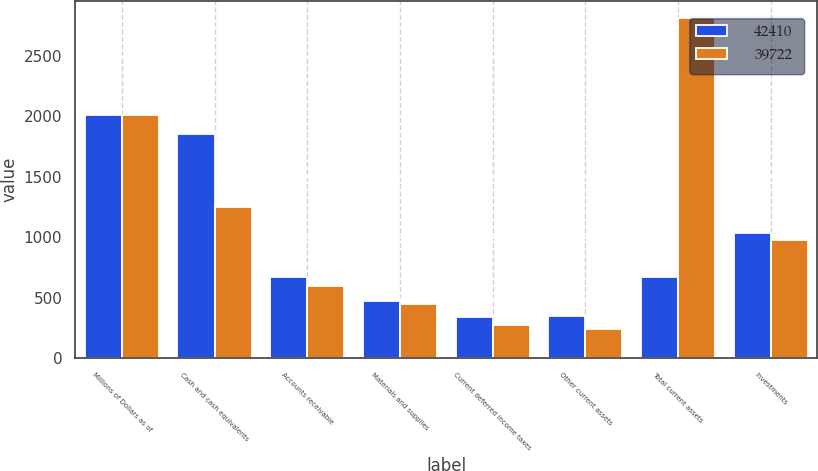Convert chart to OTSL. <chart><loc_0><loc_0><loc_500><loc_500><stacked_bar_chart><ecel><fcel>Millions of Dollars as of<fcel>Cash and cash equivalents<fcel>Accounts receivable<fcel>Materials and supplies<fcel>Current deferred income taxes<fcel>Other current assets<fcel>Total current assets<fcel>Investments<nl><fcel>42410<fcel>2009<fcel>1850<fcel>666<fcel>475<fcel>339<fcel>350<fcel>666<fcel>1036<nl><fcel>39722<fcel>2008<fcel>1249<fcel>594<fcel>450<fcel>276<fcel>244<fcel>2813<fcel>974<nl></chart> 